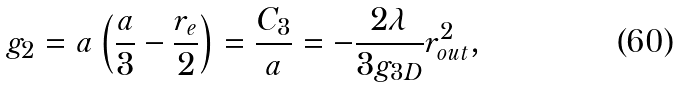<formula> <loc_0><loc_0><loc_500><loc_500>g _ { 2 } = a \left ( \frac { a } { 3 } - \frac { r _ { e } } { 2 } \right ) = \frac { C _ { 3 } } { a } = - \frac { 2 \lambda } { 3 g _ { 3 D } } r _ { o u t } ^ { 2 } ,</formula> 